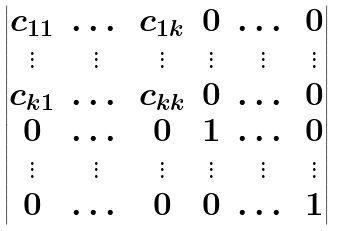Convert formula to latex. <formula><loc_0><loc_0><loc_500><loc_500>\begin{vmatrix} c _ { 1 1 } & \dots & c _ { 1 k } & 0 & \dots & 0 \\ \vdots & \vdots & \vdots & \vdots & \vdots & \vdots \\ c _ { k 1 } & \dots & c _ { k k } & 0 & \dots & 0 \\ 0 & \dots & 0 & 1 & \dots & 0 \\ \vdots & \vdots & \vdots & \vdots & \vdots & \vdots \\ 0 & \dots & 0 & 0 & \dots & 1 \end{vmatrix}</formula> 